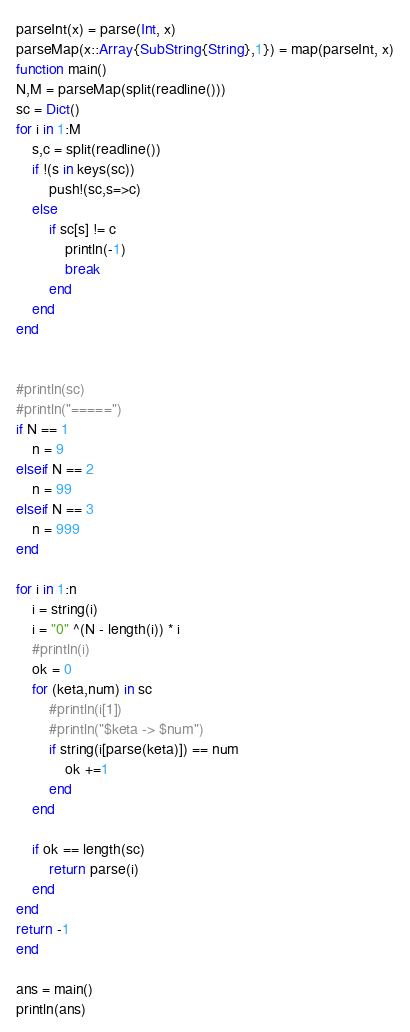Convert code to text. <code><loc_0><loc_0><loc_500><loc_500><_Julia_>parseInt(x) = parse(Int, x)
parseMap(x::Array{SubString{String},1}) = map(parseInt, x)
function main()
N,M = parseMap(split(readline()))
sc = Dict()
for i in 1:M
    s,c = split(readline())
    if !(s in keys(sc))
        push!(sc,s=>c)
    else
        if sc[s] != c
            println(-1)
            break
        end
    end
end


#println(sc)
#println("=====")
if N == 1
    n = 9
elseif N == 2
    n = 99
elseif N == 3
    n = 999
end

for i in 1:n
    i = string(i)
    i = "0" ^(N - length(i)) * i
    #println(i)
    ok = 0
    for (keta,num) in sc
        #println(i[1])
        #println("$keta -> $num")
        if string(i[parse(keta)]) == num
            ok +=1
        end
    end

    if ok == length(sc)
        return parse(i)
    end
end             
return -1   
end

ans = main()
println(ans)</code> 